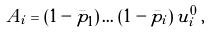Convert formula to latex. <formula><loc_0><loc_0><loc_500><loc_500>A _ { i } = ( 1 - \bar { p } _ { 1 } ) \, \dots \, ( 1 - \bar { p } _ { i } ) \, u _ { i } ^ { 0 } \, ,</formula> 